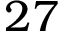<formula> <loc_0><loc_0><loc_500><loc_500>2 7</formula> 